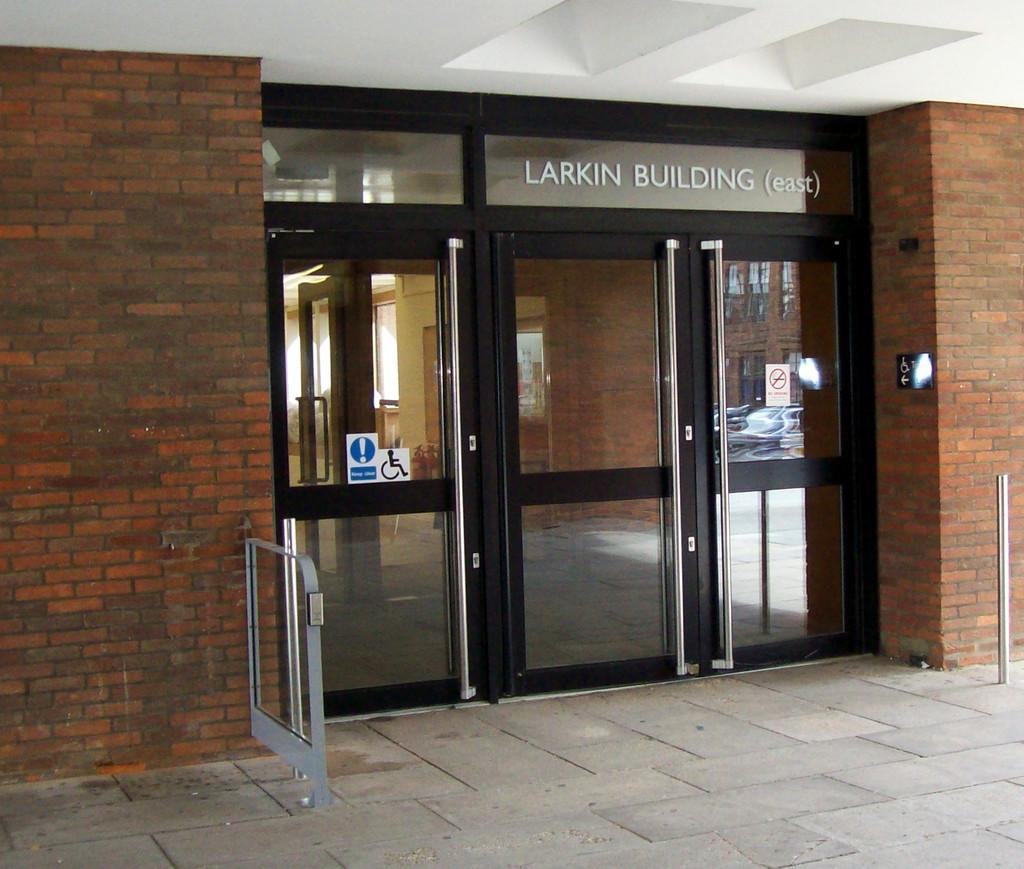How would you summarize this image in a sentence or two? In this picture I can see there is a glass door and there is a brick wall into left and right. There are few labels pasted on the door. 